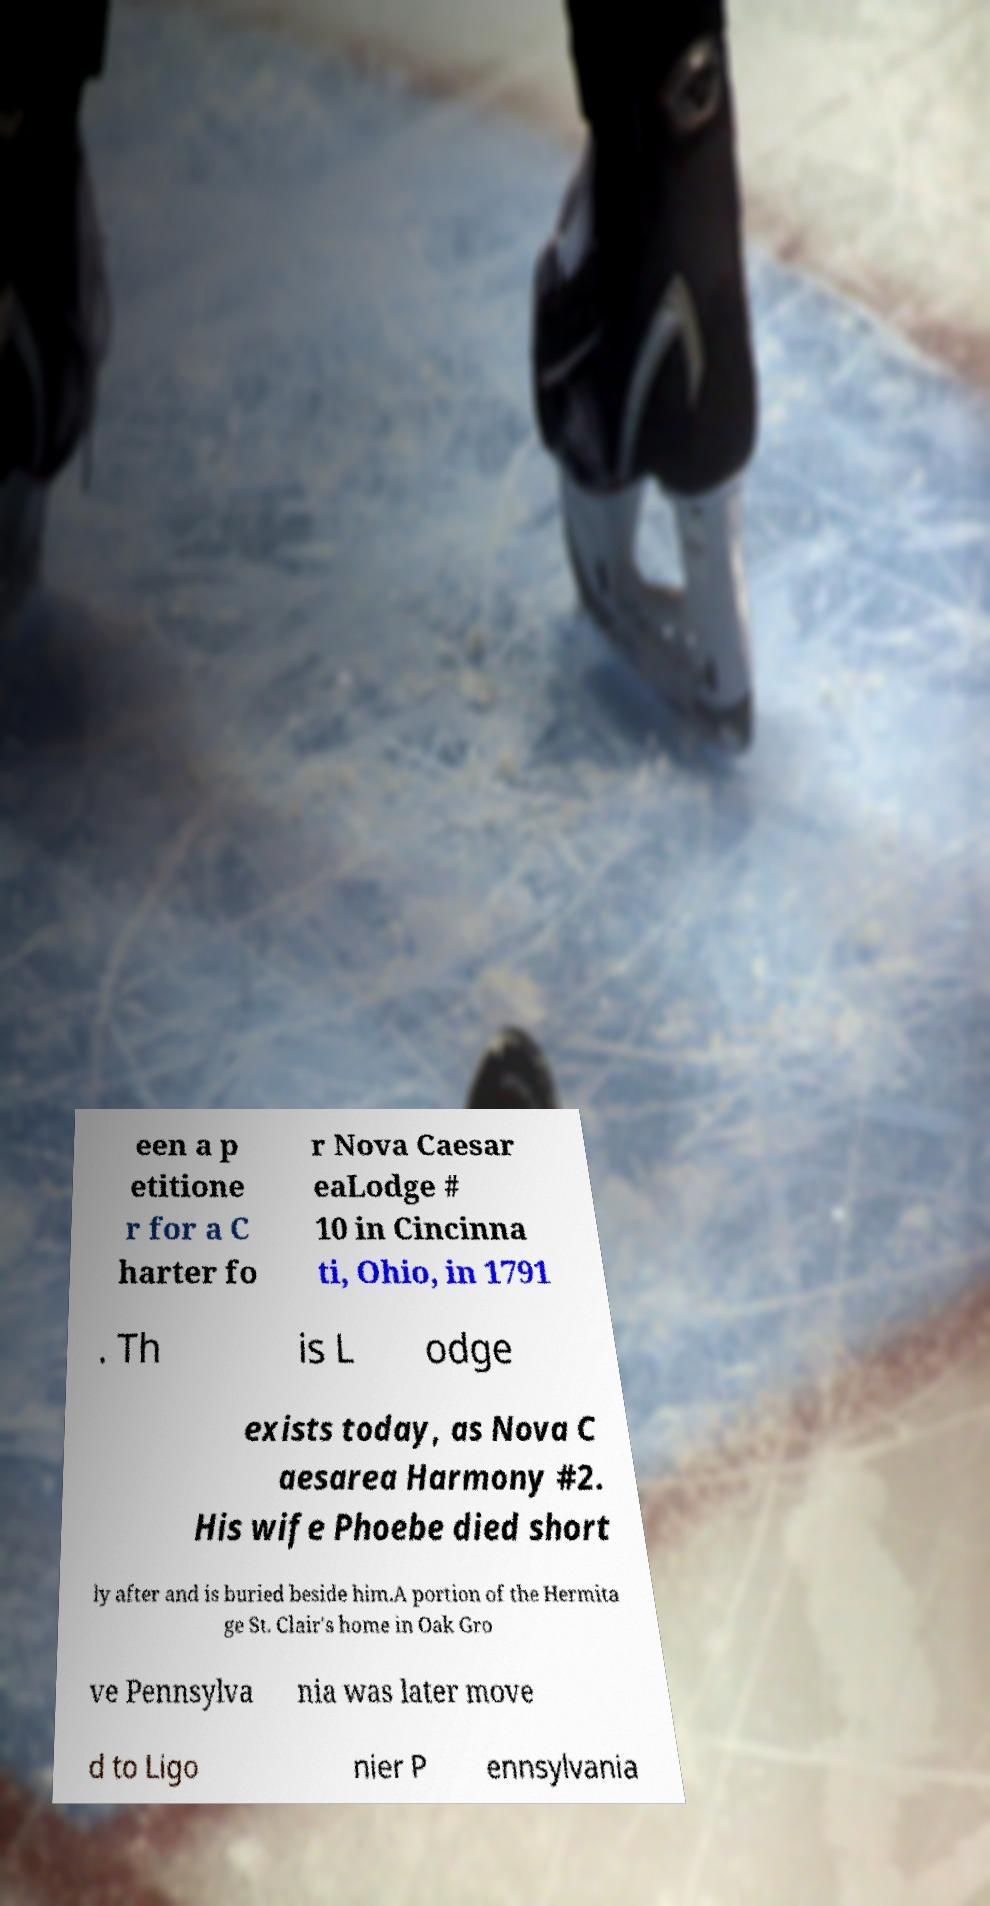Please identify and transcribe the text found in this image. een a p etitione r for a C harter fo r Nova Caesar eaLodge # 10 in Cincinna ti, Ohio, in 1791 . Th is L odge exists today, as Nova C aesarea Harmony #2. His wife Phoebe died short ly after and is buried beside him.A portion of the Hermita ge St. Clair's home in Oak Gro ve Pennsylva nia was later move d to Ligo nier P ennsylvania 